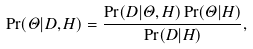Convert formula to latex. <formula><loc_0><loc_0><loc_500><loc_500>\Pr ( \Theta | D , H ) = \frac { \Pr ( D | \Theta , H ) \Pr ( \Theta | H ) } { \Pr ( D | H ) } ,</formula> 